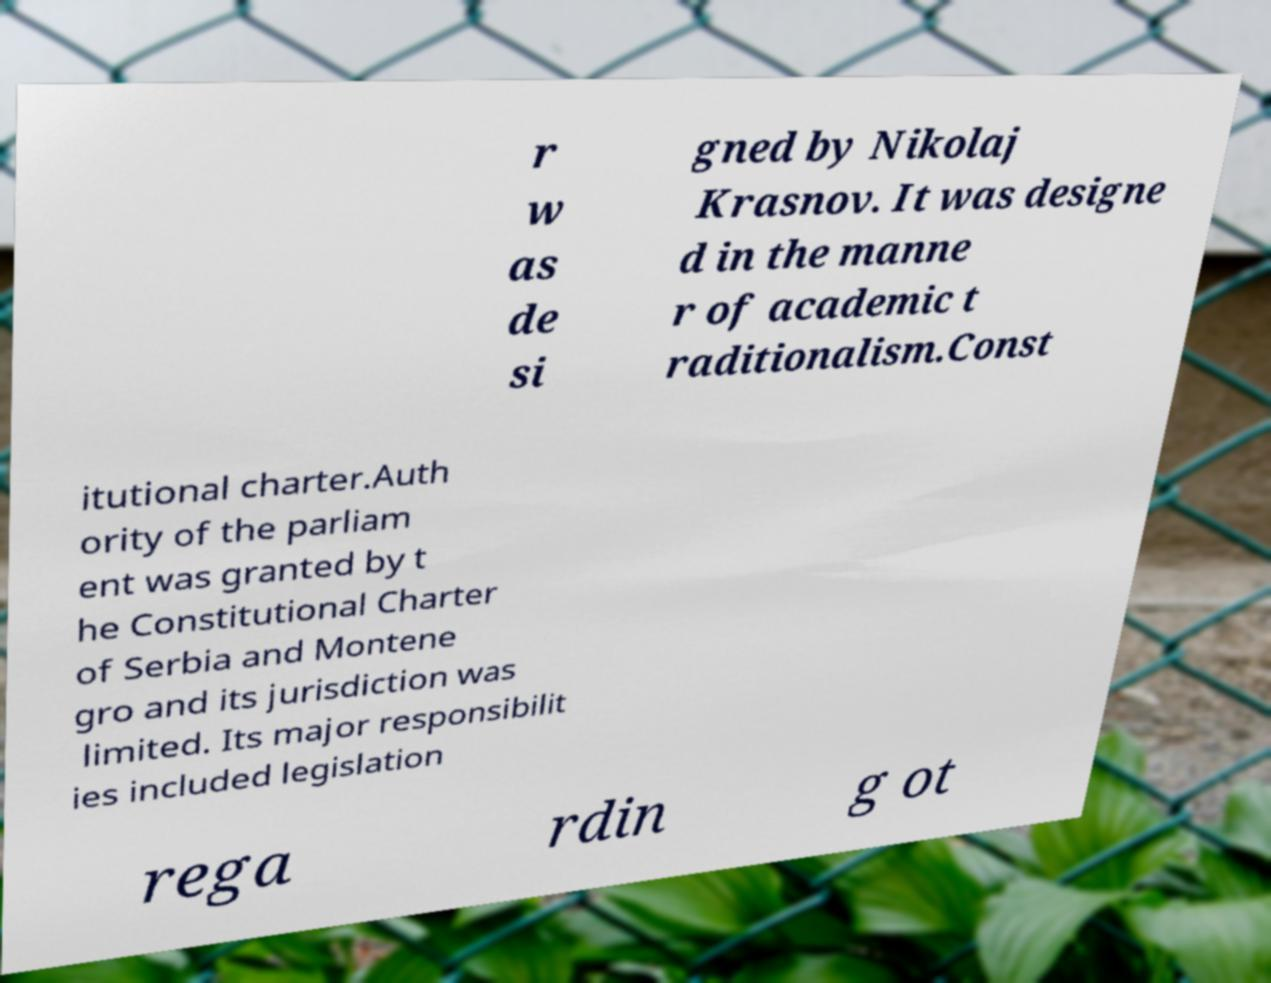Can you read and provide the text displayed in the image?This photo seems to have some interesting text. Can you extract and type it out for me? r w as de si gned by Nikolaj Krasnov. It was designe d in the manne r of academic t raditionalism.Const itutional charter.Auth ority of the parliam ent was granted by t he Constitutional Charter of Serbia and Montene gro and its jurisdiction was limited. Its major responsibilit ies included legislation rega rdin g ot 